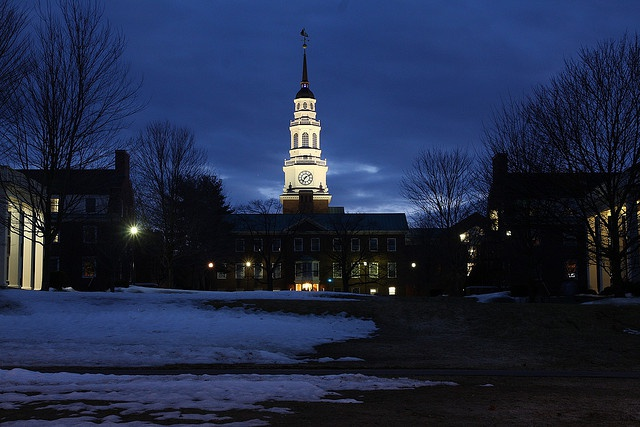Describe the objects in this image and their specific colors. I can see a clock in navy, ivory, darkgray, gray, and black tones in this image. 